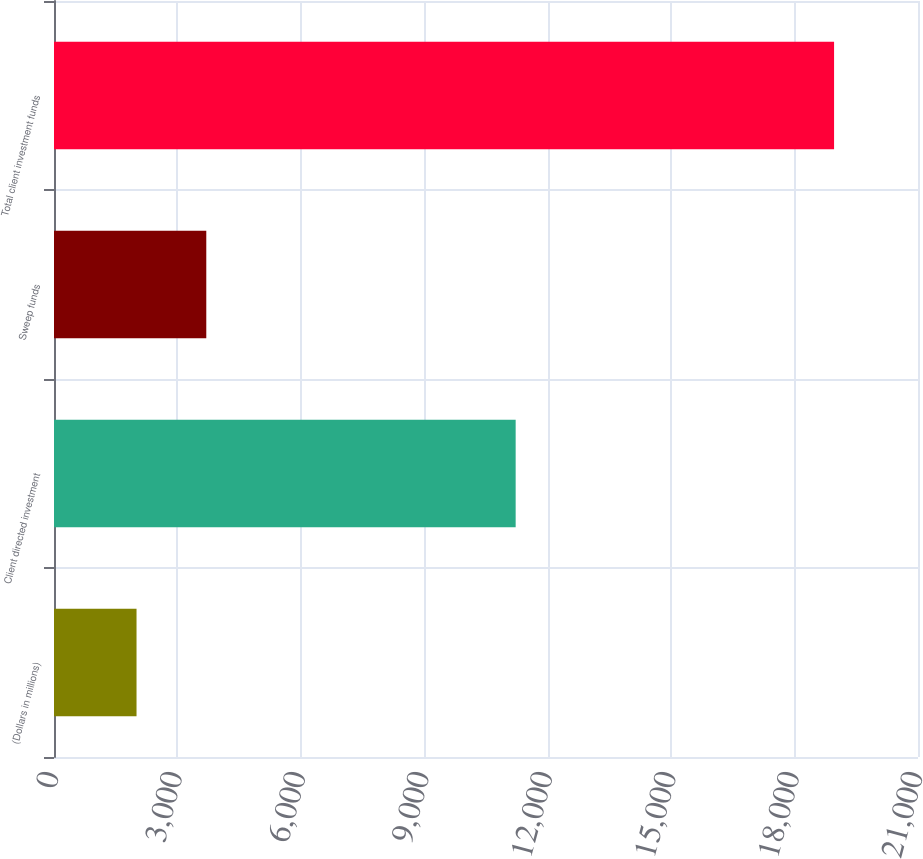Convert chart to OTSL. <chart><loc_0><loc_0><loc_500><loc_500><bar_chart><fcel>(Dollars in millions)<fcel>Client directed investment<fcel>Sweep funds<fcel>Total client investment funds<nl><fcel>2006<fcel>11221<fcel>3701.4<fcel>18960<nl></chart> 